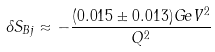<formula> <loc_0><loc_0><loc_500><loc_500>\delta S _ { B j } \approx - \frac { ( 0 . 0 1 5 \pm 0 . 0 1 3 ) G e V ^ { 2 } } { Q ^ { 2 } }</formula> 